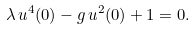<formula> <loc_0><loc_0><loc_500><loc_500>\lambda \, u ^ { 4 } ( 0 ) - g \, u ^ { 2 } ( 0 ) + 1 = 0 .</formula> 